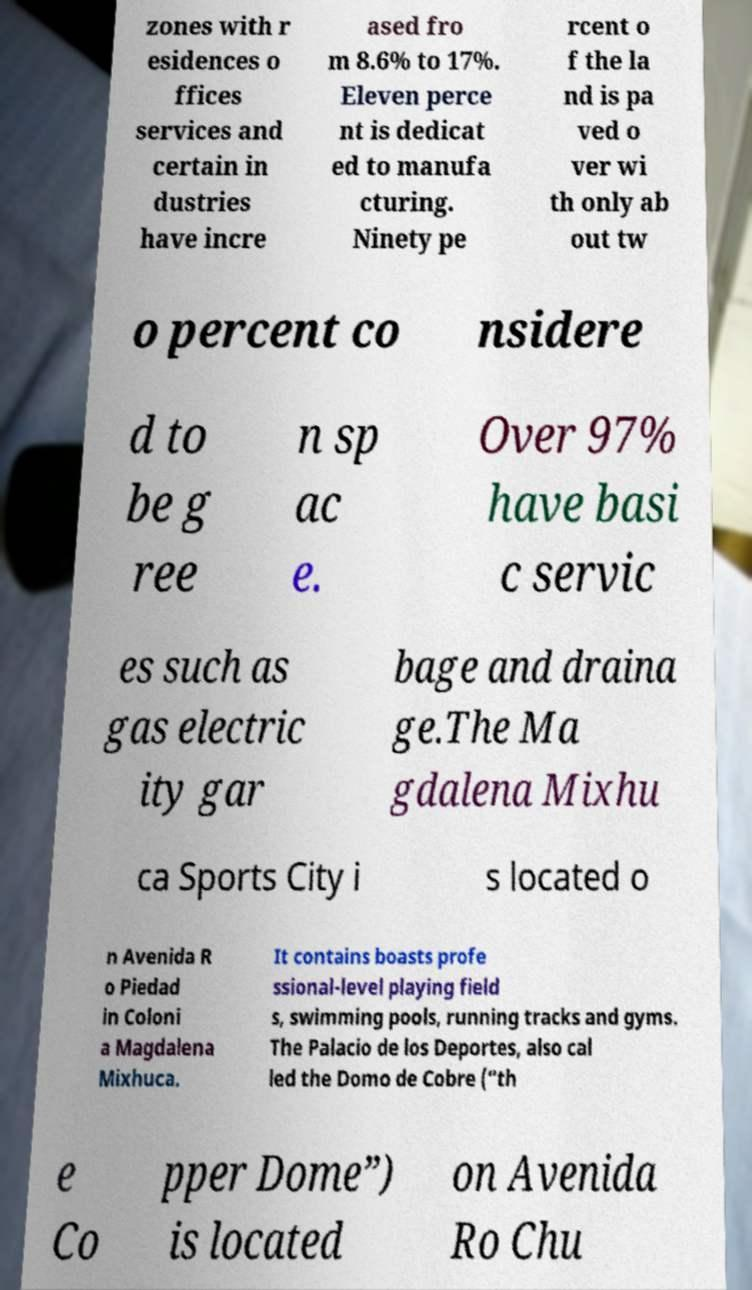Could you extract and type out the text from this image? zones with r esidences o ffices services and certain in dustries have incre ased fro m 8.6% to 17%. Eleven perce nt is dedicat ed to manufa cturing. Ninety pe rcent o f the la nd is pa ved o ver wi th only ab out tw o percent co nsidere d to be g ree n sp ac e. Over 97% have basi c servic es such as gas electric ity gar bage and draina ge.The Ma gdalena Mixhu ca Sports City i s located o n Avenida R o Piedad in Coloni a Magdalena Mixhuca. It contains boasts profe ssional-level playing field s, swimming pools, running tracks and gyms. The Palacio de los Deportes, also cal led the Domo de Cobre (“th e Co pper Dome”) is located on Avenida Ro Chu 